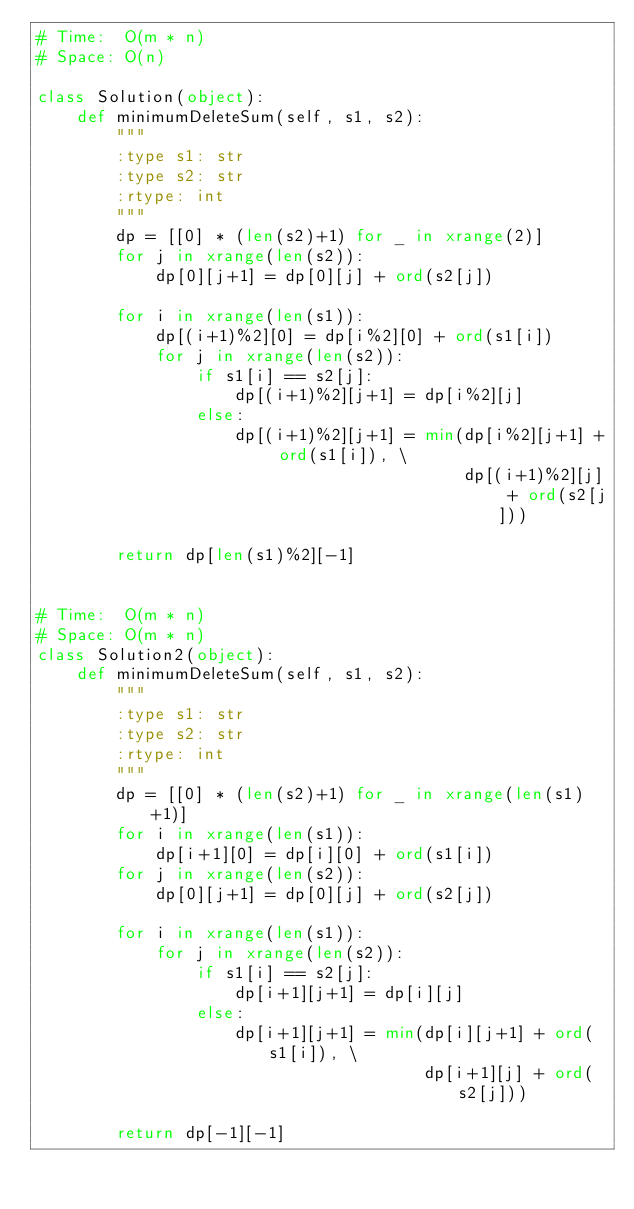<code> <loc_0><loc_0><loc_500><loc_500><_Python_># Time:  O(m * n)
# Space: O(n)

class Solution(object):
    def minimumDeleteSum(self, s1, s2):
        """
        :type s1: str
        :type s2: str
        :rtype: int
        """
        dp = [[0] * (len(s2)+1) for _ in xrange(2)]
        for j in xrange(len(s2)):
            dp[0][j+1] = dp[0][j] + ord(s2[j])

        for i in xrange(len(s1)):
            dp[(i+1)%2][0] = dp[i%2][0] + ord(s1[i])
            for j in xrange(len(s2)):
                if s1[i] == s2[j]:
                    dp[(i+1)%2][j+1] = dp[i%2][j]
                else:
                    dp[(i+1)%2][j+1] = min(dp[i%2][j+1] + ord(s1[i]), \
                                           dp[(i+1)%2][j] + ord(s2[j]))

        return dp[len(s1)%2][-1]


# Time:  O(m * n)
# Space: O(m * n)
class Solution2(object):
    def minimumDeleteSum(self, s1, s2):
        """
        :type s1: str
        :type s2: str
        :rtype: int
        """
        dp = [[0] * (len(s2)+1) for _ in xrange(len(s1)+1)]
        for i in xrange(len(s1)):
            dp[i+1][0] = dp[i][0] + ord(s1[i])
        for j in xrange(len(s2)):
            dp[0][j+1] = dp[0][j] + ord(s2[j])

        for i in xrange(len(s1)):
            for j in xrange(len(s2)):
                if s1[i] == s2[j]:
                    dp[i+1][j+1] = dp[i][j]
                else:
                    dp[i+1][j+1] = min(dp[i][j+1] + ord(s1[i]), \
                                       dp[i+1][j] + ord(s2[j]))

        return dp[-1][-1]

</code> 